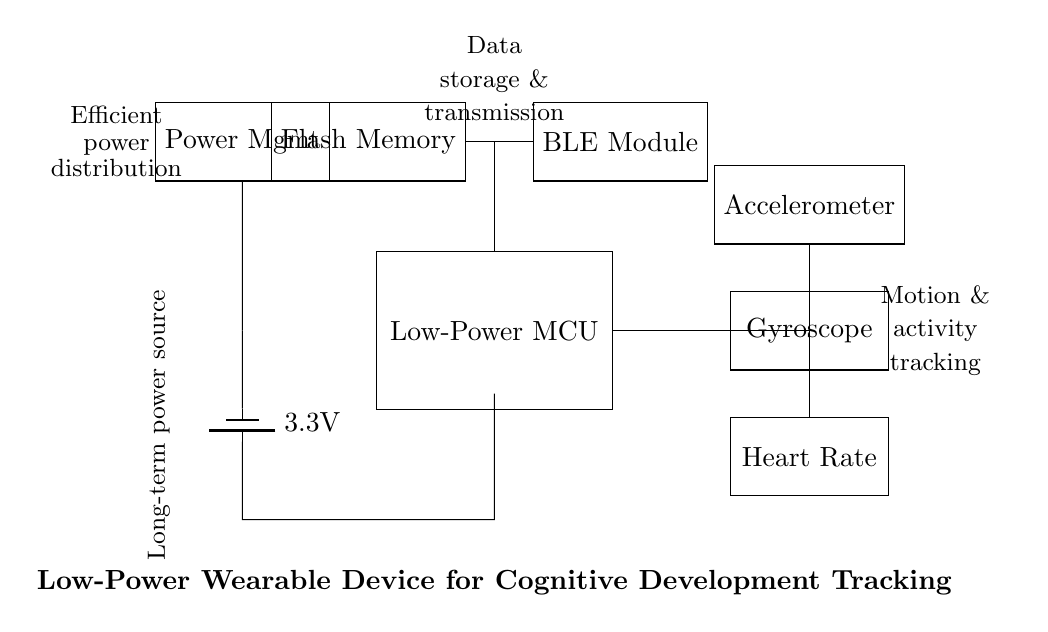What is the voltage of the power source? The circuit shows a battery labeled as providing a voltage of 3.3 volts. This is indicated near the battery symbol in the diagram.
Answer: 3.3 volts What type of sensors are included in this circuit? The circuit includes three sensors: an accelerometer, a gyroscope, and a heart rate monitor. Each is represented as a rectangle with its name inside.
Answer: Accelerometer, gyroscope, heart rate What is the role of the flash memory component? The flash memory in this circuit is used for data storage. This function is indicated by its connection to the microcontroller, which suggests that data collected by the sensors will be stored here.
Answer: Data storage Which module is used for wireless communication? The circuit features a BLE (Bluetooth Low Energy) module designed for wireless communication. This is indicated by its label in the diagram.
Answer: BLE module How does power management connect to the circuit? The power management component provides power to the entire circuit, including the battery. Its connection to the battery and other components indicates it distributes the power efficiently, as described in the labels in the diagram.
Answer: Provides power to the circuit Explain how the accelerometer connects to the microcontroller. The accelerometer connects to the microcontroller through a wire that branches off from the microcontroller. This connection is depicted using a line that indicates the path for data transfer which is common in microcontroller circuits for data collection.
Answer: Through a branching wire to microcontroller What is the significance of the labels next to each component? The labels next to each component provide essential information about the function of each part in the circuit. They help identify the circuits and simplify understanding of the overall system layout, showing what each component does.
Answer: To identify component functions 